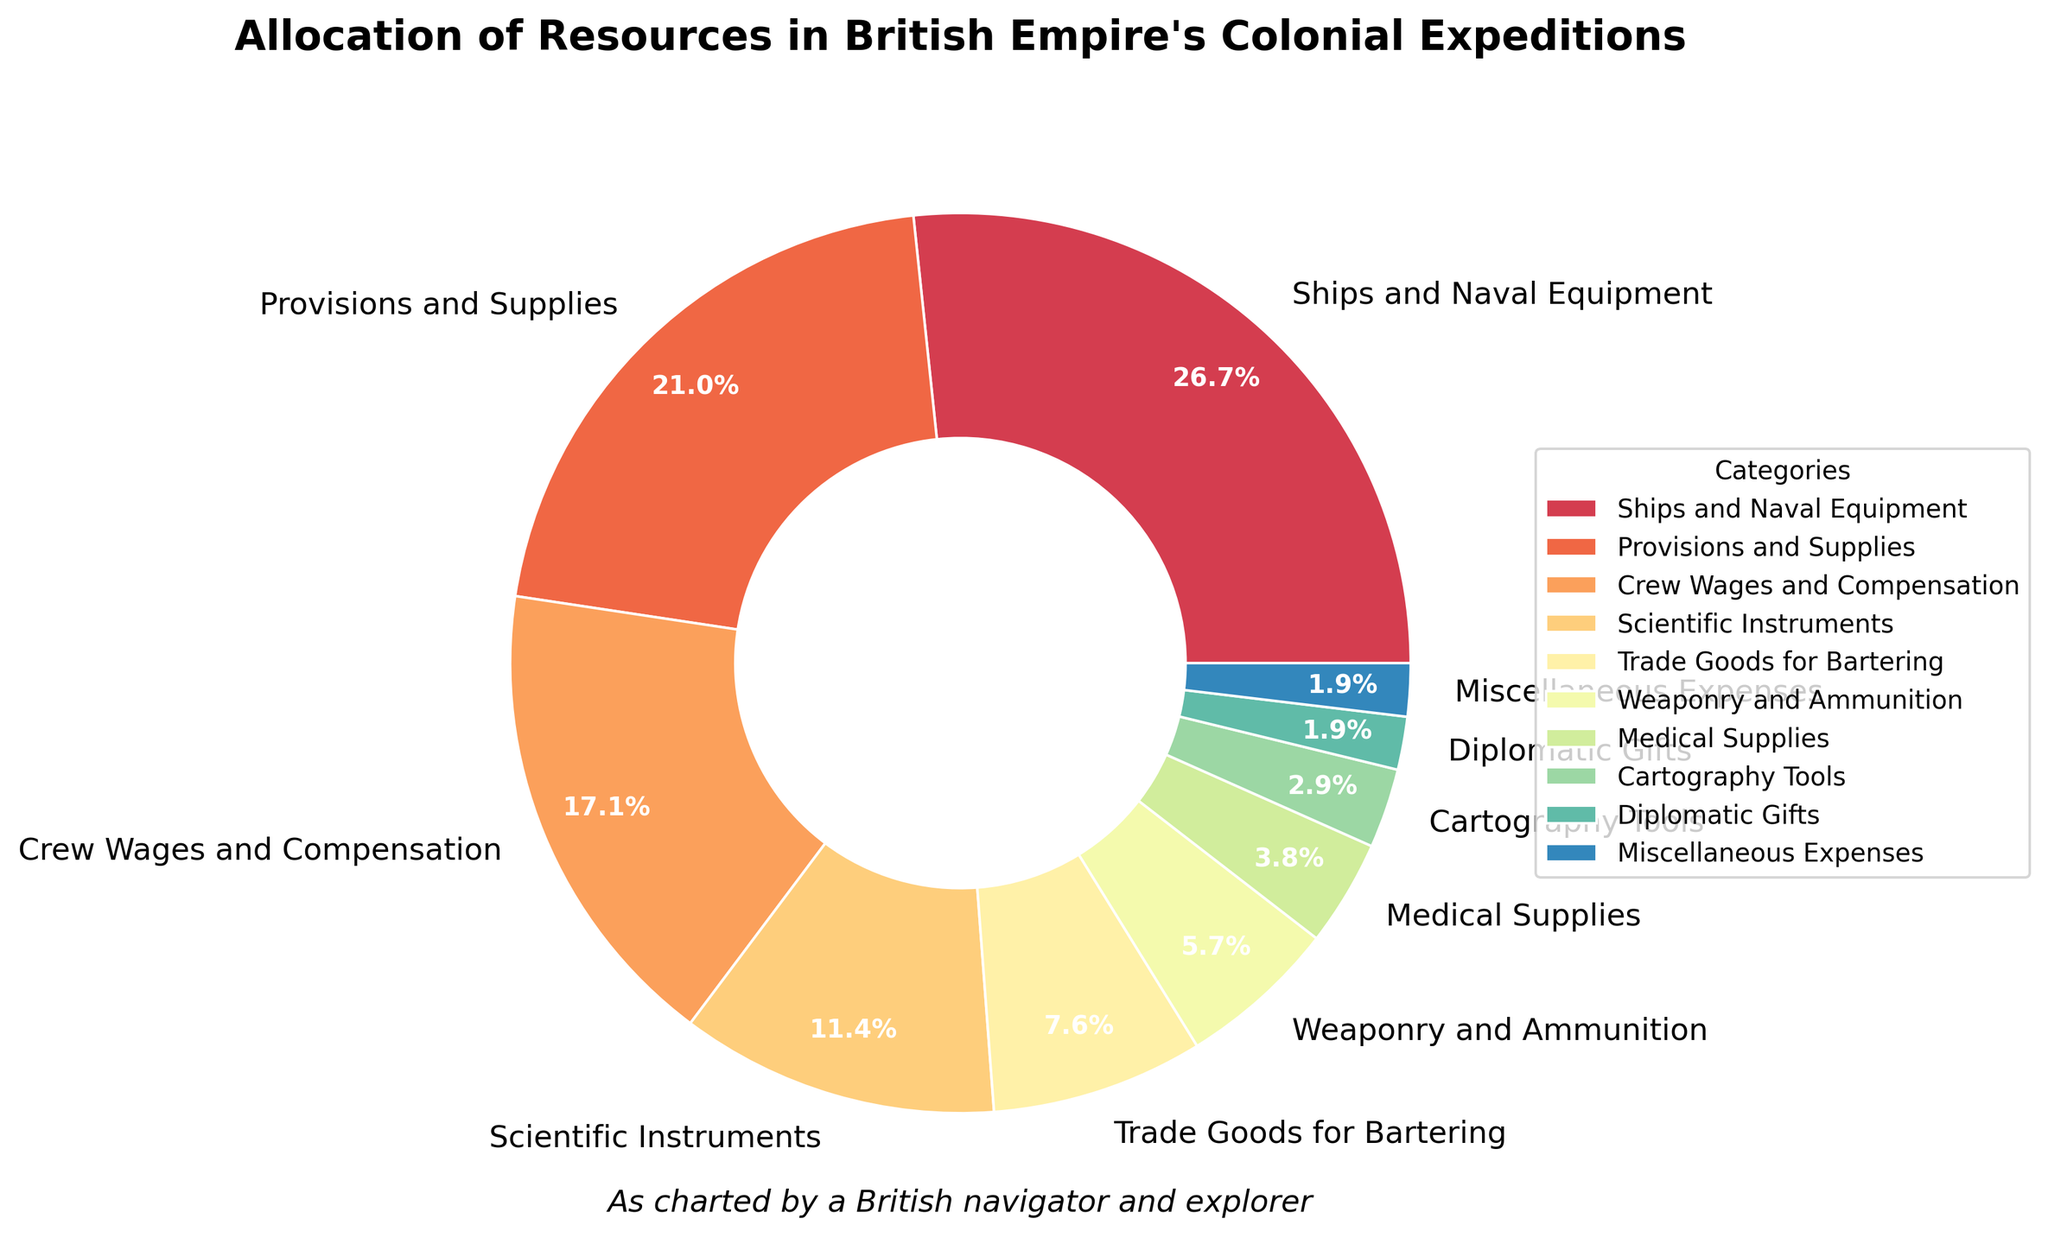Which category has the highest allocation percentage? By looking at the pie chart, locate the category with the largest wedge, which in this case is 'Ships and Naval Equipment'.
Answer: Ships and Naval Equipment Which two categories together constitute 40% of the allocation? Add the percentages of several category pairs to find which combination totals 40%. 'Ships and Naval Equipment' (28%) + 'Provisions and Supplies' (22%) = 50%, which is incorrect. 'Crew Wages and Compensation' (18%) + 'Scientific Instruments' (12%) = 30%, incorrect. 'Provisions and Supplies' (22%) + 'Crew Wages and Compensation' (18%) = 40%, correct.
Answer: Provisions and Supplies and Crew Wages and Compensation What is the difference in percentage points between the allocation for 'Weaponry and Ammunition' and 'Scientific Instruments'? Subtract the percentage of 'Weaponry and Ammunition' (6%) from that of 'Scientific Instruments' (12%). The difference is 12% - 6% = 6%.
Answer: 6% Which category has a slightly larger allocation, 'Medical Supplies' or 'Trade Goods for Bartering'? Compare the percentage of 'Medical Supplies' (4%) with 'Trade Goods for Bartering' (8%). The latter is larger.
Answer: Trade Goods for Bartering What is the sum of the allocations for 'Medical Supplies', 'Cartography Tools', and 'Diplomatic Gifts'? Add the percentages for 'Medical Supplies' (4%), 'Cartography Tools' (3%), and 'Diplomatic Gifts' (2%). The sum is 4% + 3% + 2% = 9%.
Answer: 9% Which category is represented by the smallest wedge in the pie chart? Identify the smallest wedge in the pie chart, which corresponds to 'Miscellaneous Expenses'.
Answer: Miscellaneous Expenses How many categories have an allocation percentage of less than 10%? Count the categories whose allocation percentages are below 10% by examining the legend or the wedges in the pie chart. The categories are 'Trade Goods for Bartering' (8%), 'Weaponry and Ammunition' (6%), 'Medical Supplies' (4%), 'Cartography Tools' (3%), 'Diplomatic Gifts' (2%), and 'Miscellaneous Expenses' (2%).
Answer: 6 Is the allocation for 'Provisions and Supplies' greater than the combined allocation for 'Weaponry and Ammunition' and 'Medical Supplies'? Add the percentages for 'Weaponry and Ammunition' (6%) and 'Medical Supplies' (4%) to get 10%. Compare this with 'Provisions and Supplies' which is 22%, and note that 22% > 10%.
Answer: Yes 